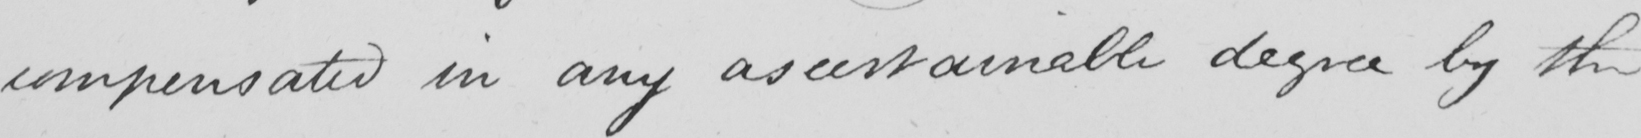Please provide the text content of this handwritten line. compensated in any ascertainable degree by the 